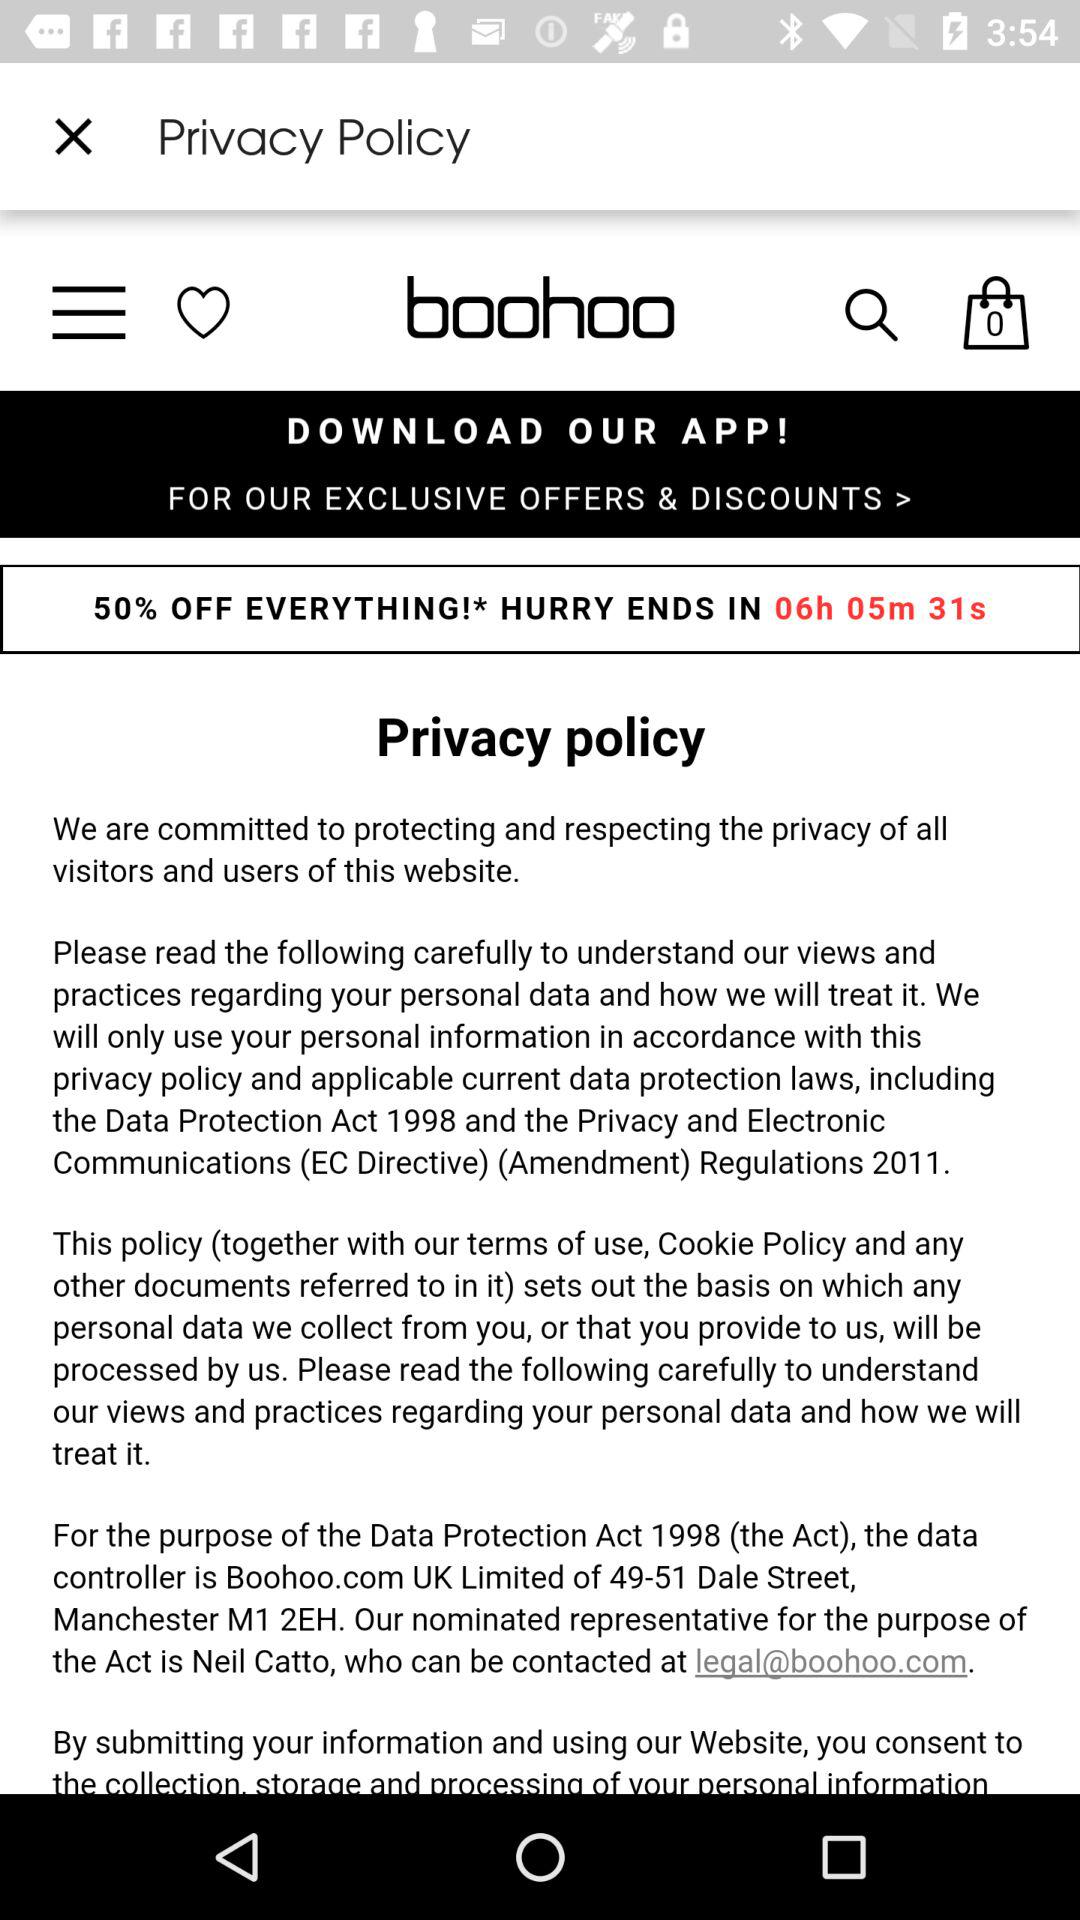How much time is left for this offer? The remaining time for this offer is 6 hours, 5 minutes, and 31 seconds. 